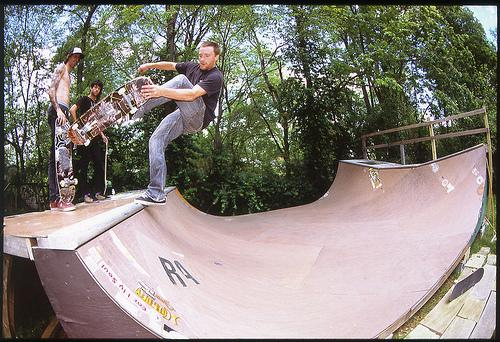Question: what activity is being performed here?
Choices:
A. Knitting.
B. Dancing.
C. Skateboarding.
D. Roller skating.
Answer with the letter. Answer: C Question: how many people appear in this photo?
Choices:
A. Five.
B. Two.
C. Three.
D. Four.
Answer with the letter. Answer: C Question: what color are the trees in the background?
Choices:
A. Green.
B. Yellow.
C. Brown.
D. Red.
Answer with the letter. Answer: A Question: what color is the skateboarder's shirt?
Choices:
A. Blue.
B. White.
C. Black.
D. Green.
Answer with the letter. Answer: C Question: where was this picture taken?
Choices:
A. Movie theater.
B. A half pipe.
C. Classroom.
D. Restaurant.
Answer with the letter. Answer: B 